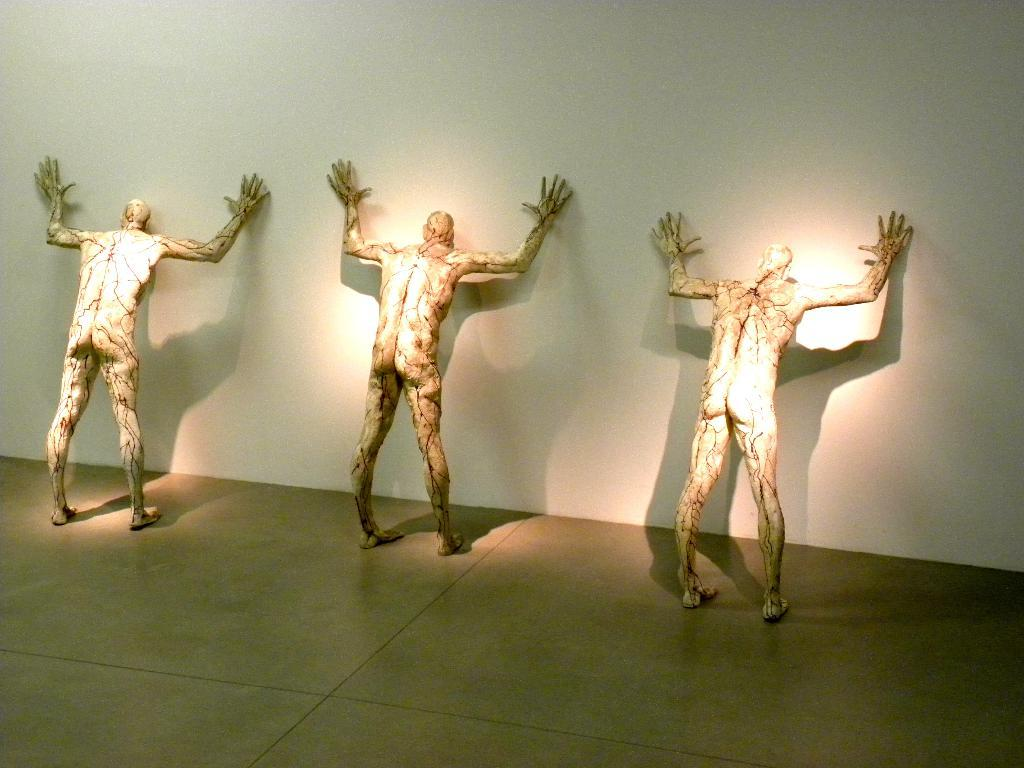What can be seen in the image? There are statues in the image. Where are the statues located in relation to other elements in the image? The statues are near a wall. What type of rifle is the mom holding in the image? There is no mom or rifle present in the image; it only features statues near a wall. 